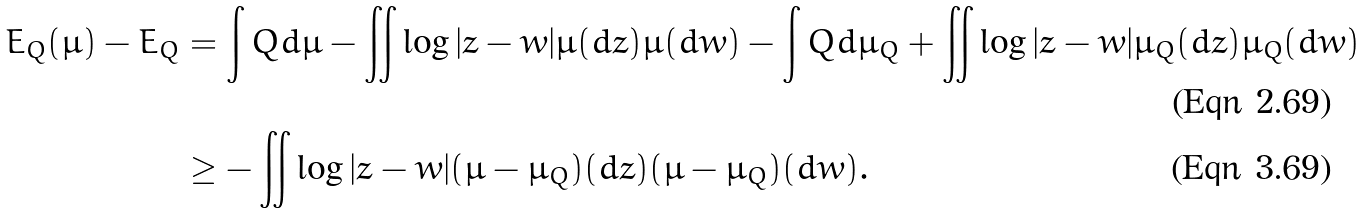Convert formula to latex. <formula><loc_0><loc_0><loc_500><loc_500>E _ { Q } ( \mu ) - E _ { Q } & = \int Q d \mu - \iint \log | z - w | \mu ( d z ) \mu ( d w ) - \int Q d \mu _ { Q } + \iint \log | z - w | \mu _ { Q } ( d z ) \mu _ { Q } ( d w ) \\ & \geq - \iint \log | z - w | ( \mu - \mu _ { Q } ) ( d z ) ( \mu - \mu _ { Q } ) ( d w ) .</formula> 